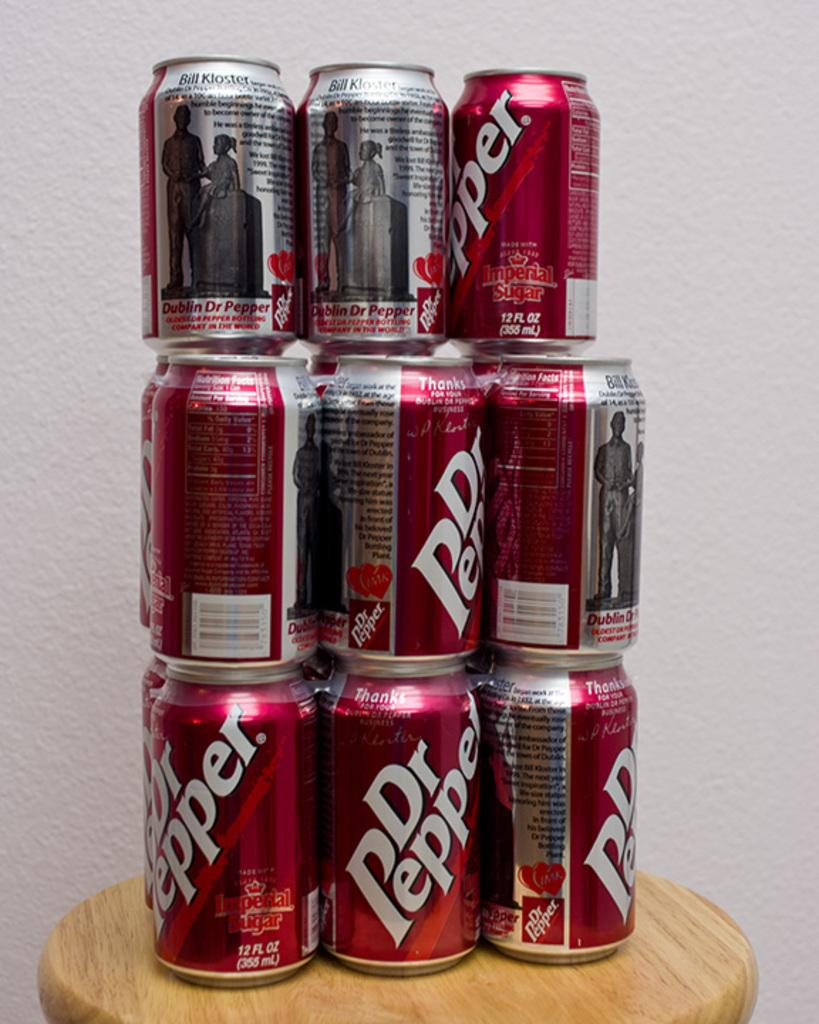Provide a one-sentence caption for the provided image. A stack of Dr Pepper cans that are on a wooden stool. 